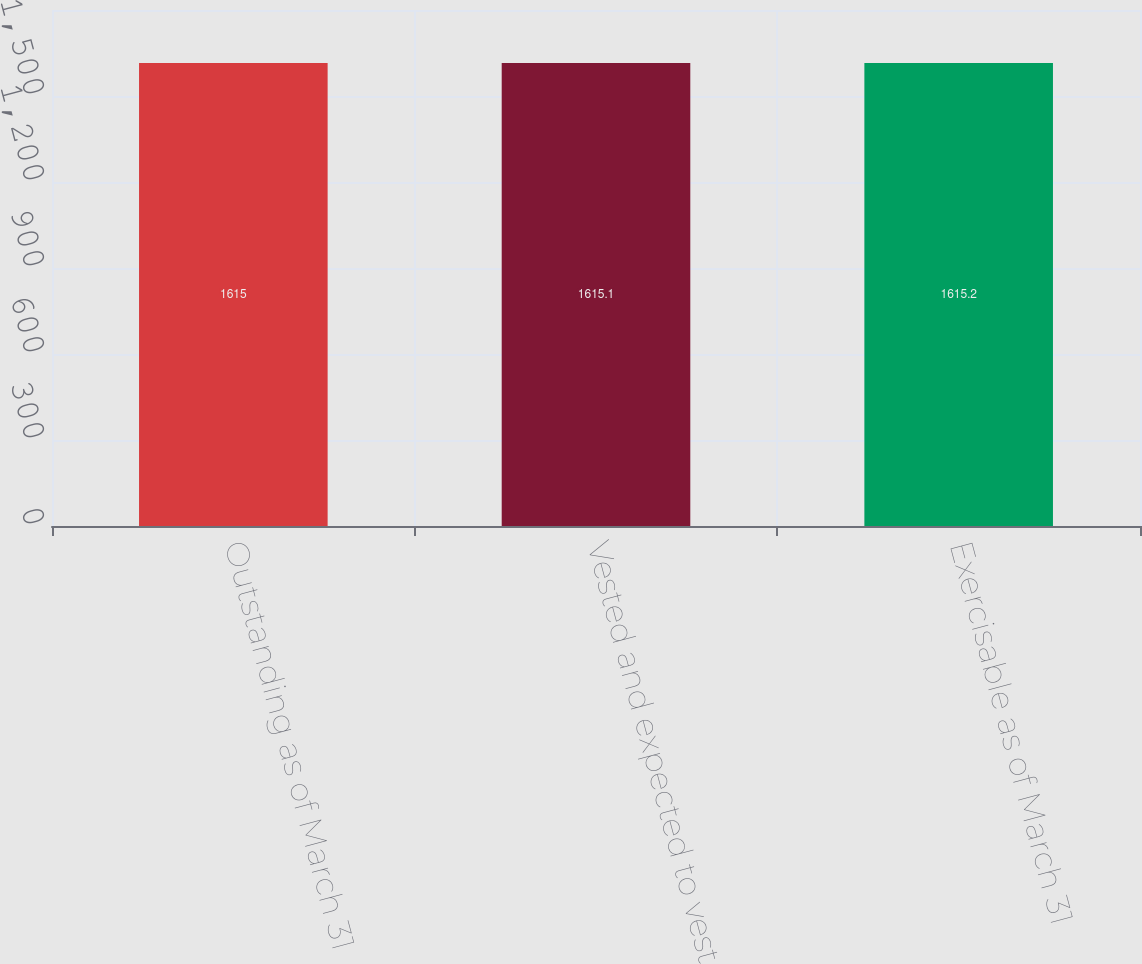Convert chart. <chart><loc_0><loc_0><loc_500><loc_500><bar_chart><fcel>Outstanding as of March 31<fcel>Vested and expected to vest<fcel>Exercisable as of March 31<nl><fcel>1615<fcel>1615.1<fcel>1615.2<nl></chart> 